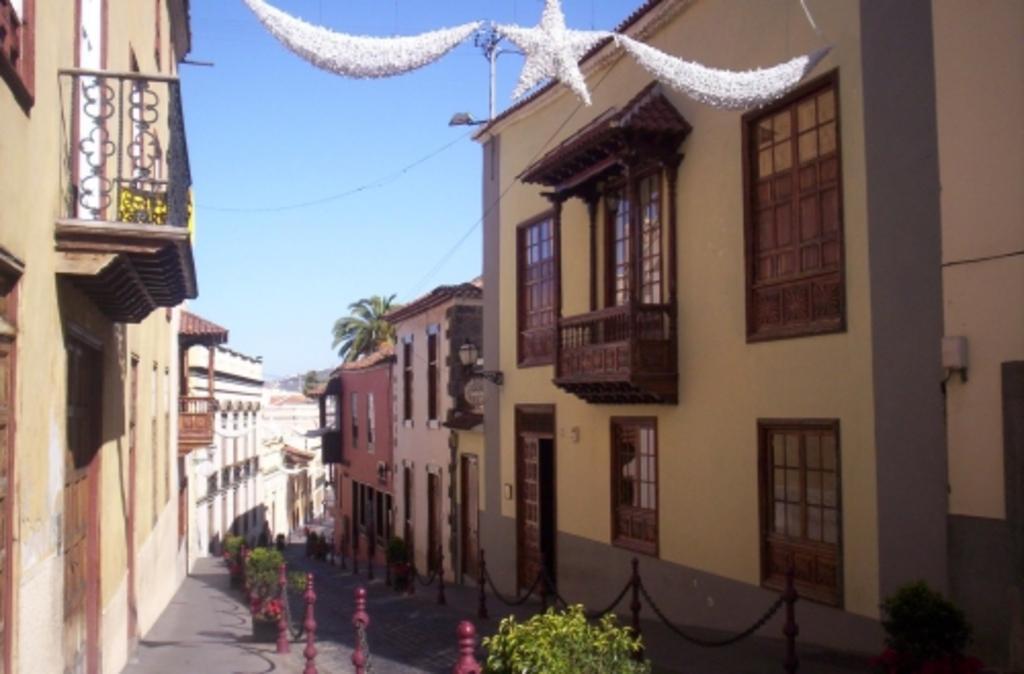Can you describe this image briefly? This image consists of many buildings. At the bottom, we can see a railing along with chains. At the top, there is sky. At the bottom, there is road. 